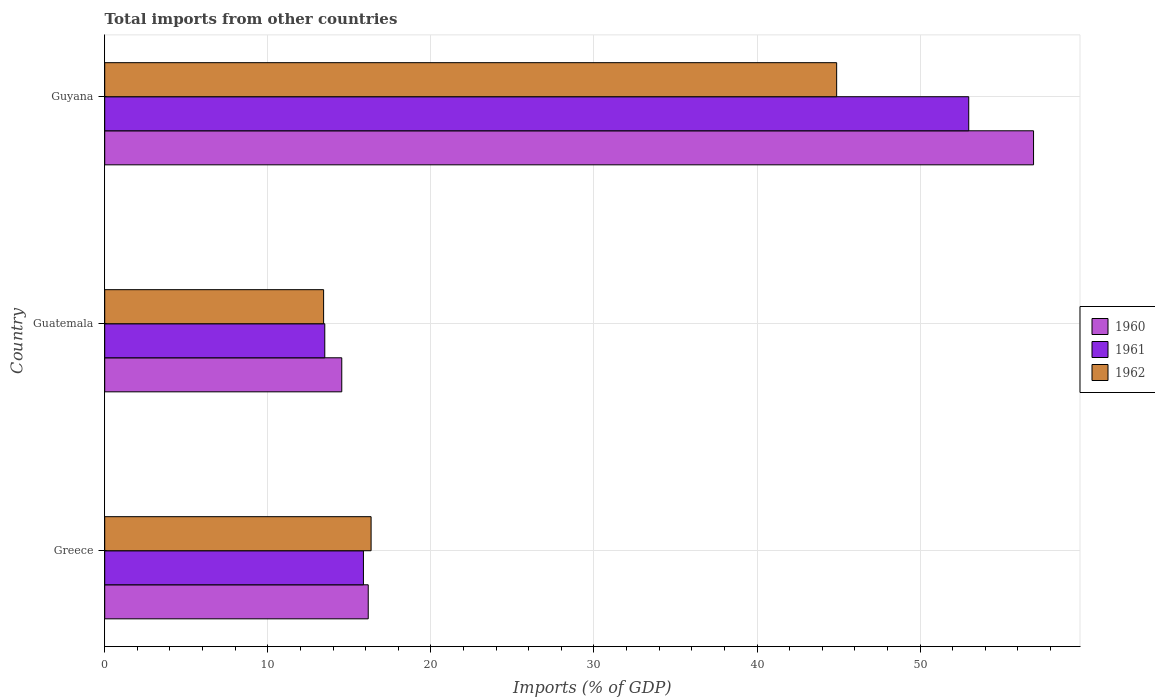How many groups of bars are there?
Offer a very short reply. 3. Are the number of bars per tick equal to the number of legend labels?
Offer a terse response. Yes. How many bars are there on the 3rd tick from the bottom?
Offer a very short reply. 3. What is the label of the 1st group of bars from the top?
Offer a terse response. Guyana. In how many cases, is the number of bars for a given country not equal to the number of legend labels?
Offer a very short reply. 0. What is the total imports in 1960 in Greece?
Your response must be concise. 16.16. Across all countries, what is the maximum total imports in 1962?
Offer a very short reply. 44.88. Across all countries, what is the minimum total imports in 1961?
Your response must be concise. 13.49. In which country was the total imports in 1962 maximum?
Make the answer very short. Guyana. In which country was the total imports in 1960 minimum?
Provide a short and direct response. Guatemala. What is the total total imports in 1960 in the graph?
Provide a short and direct response. 87.65. What is the difference between the total imports in 1961 in Greece and that in Guyana?
Provide a short and direct response. -37.12. What is the difference between the total imports in 1962 in Guyana and the total imports in 1961 in Guatemala?
Offer a terse response. 31.39. What is the average total imports in 1961 per country?
Ensure brevity in your answer.  27.45. What is the difference between the total imports in 1960 and total imports in 1962 in Guyana?
Give a very brief answer. 12.07. In how many countries, is the total imports in 1961 greater than 22 %?
Your answer should be compact. 1. What is the ratio of the total imports in 1961 in Greece to that in Guyana?
Your answer should be very brief. 0.3. Is the total imports in 1960 in Greece less than that in Guatemala?
Make the answer very short. No. What is the difference between the highest and the second highest total imports in 1960?
Your answer should be compact. 40.8. What is the difference between the highest and the lowest total imports in 1960?
Offer a very short reply. 42.42. Is the sum of the total imports in 1960 in Greece and Guyana greater than the maximum total imports in 1962 across all countries?
Give a very brief answer. Yes. How many bars are there?
Make the answer very short. 9. Are all the bars in the graph horizontal?
Offer a very short reply. Yes. What is the difference between two consecutive major ticks on the X-axis?
Your response must be concise. 10. Does the graph contain any zero values?
Make the answer very short. No. Does the graph contain grids?
Keep it short and to the point. Yes. How many legend labels are there?
Ensure brevity in your answer.  3. What is the title of the graph?
Your answer should be very brief. Total imports from other countries. Does "1971" appear as one of the legend labels in the graph?
Your answer should be compact. No. What is the label or title of the X-axis?
Your answer should be very brief. Imports (% of GDP). What is the label or title of the Y-axis?
Make the answer very short. Country. What is the Imports (% of GDP) of 1960 in Greece?
Your answer should be compact. 16.16. What is the Imports (% of GDP) in 1961 in Greece?
Your response must be concise. 15.86. What is the Imports (% of GDP) in 1962 in Greece?
Keep it short and to the point. 16.33. What is the Imports (% of GDP) in 1960 in Guatemala?
Make the answer very short. 14.54. What is the Imports (% of GDP) in 1961 in Guatemala?
Give a very brief answer. 13.49. What is the Imports (% of GDP) of 1962 in Guatemala?
Offer a very short reply. 13.42. What is the Imports (% of GDP) of 1960 in Guyana?
Provide a short and direct response. 56.96. What is the Imports (% of GDP) in 1961 in Guyana?
Provide a short and direct response. 52.98. What is the Imports (% of GDP) in 1962 in Guyana?
Ensure brevity in your answer.  44.88. Across all countries, what is the maximum Imports (% of GDP) of 1960?
Provide a short and direct response. 56.96. Across all countries, what is the maximum Imports (% of GDP) of 1961?
Your response must be concise. 52.98. Across all countries, what is the maximum Imports (% of GDP) of 1962?
Offer a very short reply. 44.88. Across all countries, what is the minimum Imports (% of GDP) of 1960?
Keep it short and to the point. 14.54. Across all countries, what is the minimum Imports (% of GDP) of 1961?
Keep it short and to the point. 13.49. Across all countries, what is the minimum Imports (% of GDP) in 1962?
Provide a succinct answer. 13.42. What is the total Imports (% of GDP) of 1960 in the graph?
Provide a succinct answer. 87.65. What is the total Imports (% of GDP) of 1961 in the graph?
Your answer should be compact. 82.34. What is the total Imports (% of GDP) of 1962 in the graph?
Provide a succinct answer. 74.64. What is the difference between the Imports (% of GDP) of 1960 in Greece and that in Guatemala?
Provide a succinct answer. 1.62. What is the difference between the Imports (% of GDP) of 1961 in Greece and that in Guatemala?
Make the answer very short. 2.37. What is the difference between the Imports (% of GDP) of 1962 in Greece and that in Guatemala?
Offer a terse response. 2.91. What is the difference between the Imports (% of GDP) of 1960 in Greece and that in Guyana?
Make the answer very short. -40.8. What is the difference between the Imports (% of GDP) in 1961 in Greece and that in Guyana?
Offer a very short reply. -37.12. What is the difference between the Imports (% of GDP) in 1962 in Greece and that in Guyana?
Provide a succinct answer. -28.55. What is the difference between the Imports (% of GDP) in 1960 in Guatemala and that in Guyana?
Keep it short and to the point. -42.42. What is the difference between the Imports (% of GDP) in 1961 in Guatemala and that in Guyana?
Ensure brevity in your answer.  -39.49. What is the difference between the Imports (% of GDP) in 1962 in Guatemala and that in Guyana?
Give a very brief answer. -31.46. What is the difference between the Imports (% of GDP) in 1960 in Greece and the Imports (% of GDP) in 1961 in Guatemala?
Offer a terse response. 2.66. What is the difference between the Imports (% of GDP) of 1960 in Greece and the Imports (% of GDP) of 1962 in Guatemala?
Offer a very short reply. 2.74. What is the difference between the Imports (% of GDP) in 1961 in Greece and the Imports (% of GDP) in 1962 in Guatemala?
Your answer should be very brief. 2.44. What is the difference between the Imports (% of GDP) of 1960 in Greece and the Imports (% of GDP) of 1961 in Guyana?
Your answer should be compact. -36.82. What is the difference between the Imports (% of GDP) in 1960 in Greece and the Imports (% of GDP) in 1962 in Guyana?
Give a very brief answer. -28.72. What is the difference between the Imports (% of GDP) of 1961 in Greece and the Imports (% of GDP) of 1962 in Guyana?
Make the answer very short. -29.02. What is the difference between the Imports (% of GDP) of 1960 in Guatemala and the Imports (% of GDP) of 1961 in Guyana?
Keep it short and to the point. -38.45. What is the difference between the Imports (% of GDP) in 1960 in Guatemala and the Imports (% of GDP) in 1962 in Guyana?
Make the answer very short. -30.35. What is the difference between the Imports (% of GDP) in 1961 in Guatemala and the Imports (% of GDP) in 1962 in Guyana?
Ensure brevity in your answer.  -31.39. What is the average Imports (% of GDP) in 1960 per country?
Provide a short and direct response. 29.22. What is the average Imports (% of GDP) of 1961 per country?
Ensure brevity in your answer.  27.45. What is the average Imports (% of GDP) in 1962 per country?
Provide a short and direct response. 24.88. What is the difference between the Imports (% of GDP) in 1960 and Imports (% of GDP) in 1961 in Greece?
Give a very brief answer. 0.29. What is the difference between the Imports (% of GDP) of 1960 and Imports (% of GDP) of 1962 in Greece?
Your answer should be very brief. -0.18. What is the difference between the Imports (% of GDP) of 1961 and Imports (% of GDP) of 1962 in Greece?
Keep it short and to the point. -0.47. What is the difference between the Imports (% of GDP) in 1960 and Imports (% of GDP) in 1961 in Guatemala?
Your answer should be compact. 1.04. What is the difference between the Imports (% of GDP) in 1960 and Imports (% of GDP) in 1962 in Guatemala?
Provide a short and direct response. 1.11. What is the difference between the Imports (% of GDP) of 1961 and Imports (% of GDP) of 1962 in Guatemala?
Provide a succinct answer. 0.07. What is the difference between the Imports (% of GDP) in 1960 and Imports (% of GDP) in 1961 in Guyana?
Your answer should be compact. 3.98. What is the difference between the Imports (% of GDP) in 1960 and Imports (% of GDP) in 1962 in Guyana?
Offer a terse response. 12.07. What is the difference between the Imports (% of GDP) of 1961 and Imports (% of GDP) of 1962 in Guyana?
Ensure brevity in your answer.  8.1. What is the ratio of the Imports (% of GDP) of 1960 in Greece to that in Guatemala?
Make the answer very short. 1.11. What is the ratio of the Imports (% of GDP) in 1961 in Greece to that in Guatemala?
Provide a succinct answer. 1.18. What is the ratio of the Imports (% of GDP) of 1962 in Greece to that in Guatemala?
Ensure brevity in your answer.  1.22. What is the ratio of the Imports (% of GDP) of 1960 in Greece to that in Guyana?
Provide a succinct answer. 0.28. What is the ratio of the Imports (% of GDP) of 1961 in Greece to that in Guyana?
Keep it short and to the point. 0.3. What is the ratio of the Imports (% of GDP) in 1962 in Greece to that in Guyana?
Give a very brief answer. 0.36. What is the ratio of the Imports (% of GDP) in 1960 in Guatemala to that in Guyana?
Your answer should be very brief. 0.26. What is the ratio of the Imports (% of GDP) of 1961 in Guatemala to that in Guyana?
Offer a terse response. 0.25. What is the ratio of the Imports (% of GDP) of 1962 in Guatemala to that in Guyana?
Make the answer very short. 0.3. What is the difference between the highest and the second highest Imports (% of GDP) of 1960?
Offer a very short reply. 40.8. What is the difference between the highest and the second highest Imports (% of GDP) in 1961?
Offer a terse response. 37.12. What is the difference between the highest and the second highest Imports (% of GDP) of 1962?
Offer a very short reply. 28.55. What is the difference between the highest and the lowest Imports (% of GDP) in 1960?
Give a very brief answer. 42.42. What is the difference between the highest and the lowest Imports (% of GDP) in 1961?
Give a very brief answer. 39.49. What is the difference between the highest and the lowest Imports (% of GDP) in 1962?
Your answer should be very brief. 31.46. 